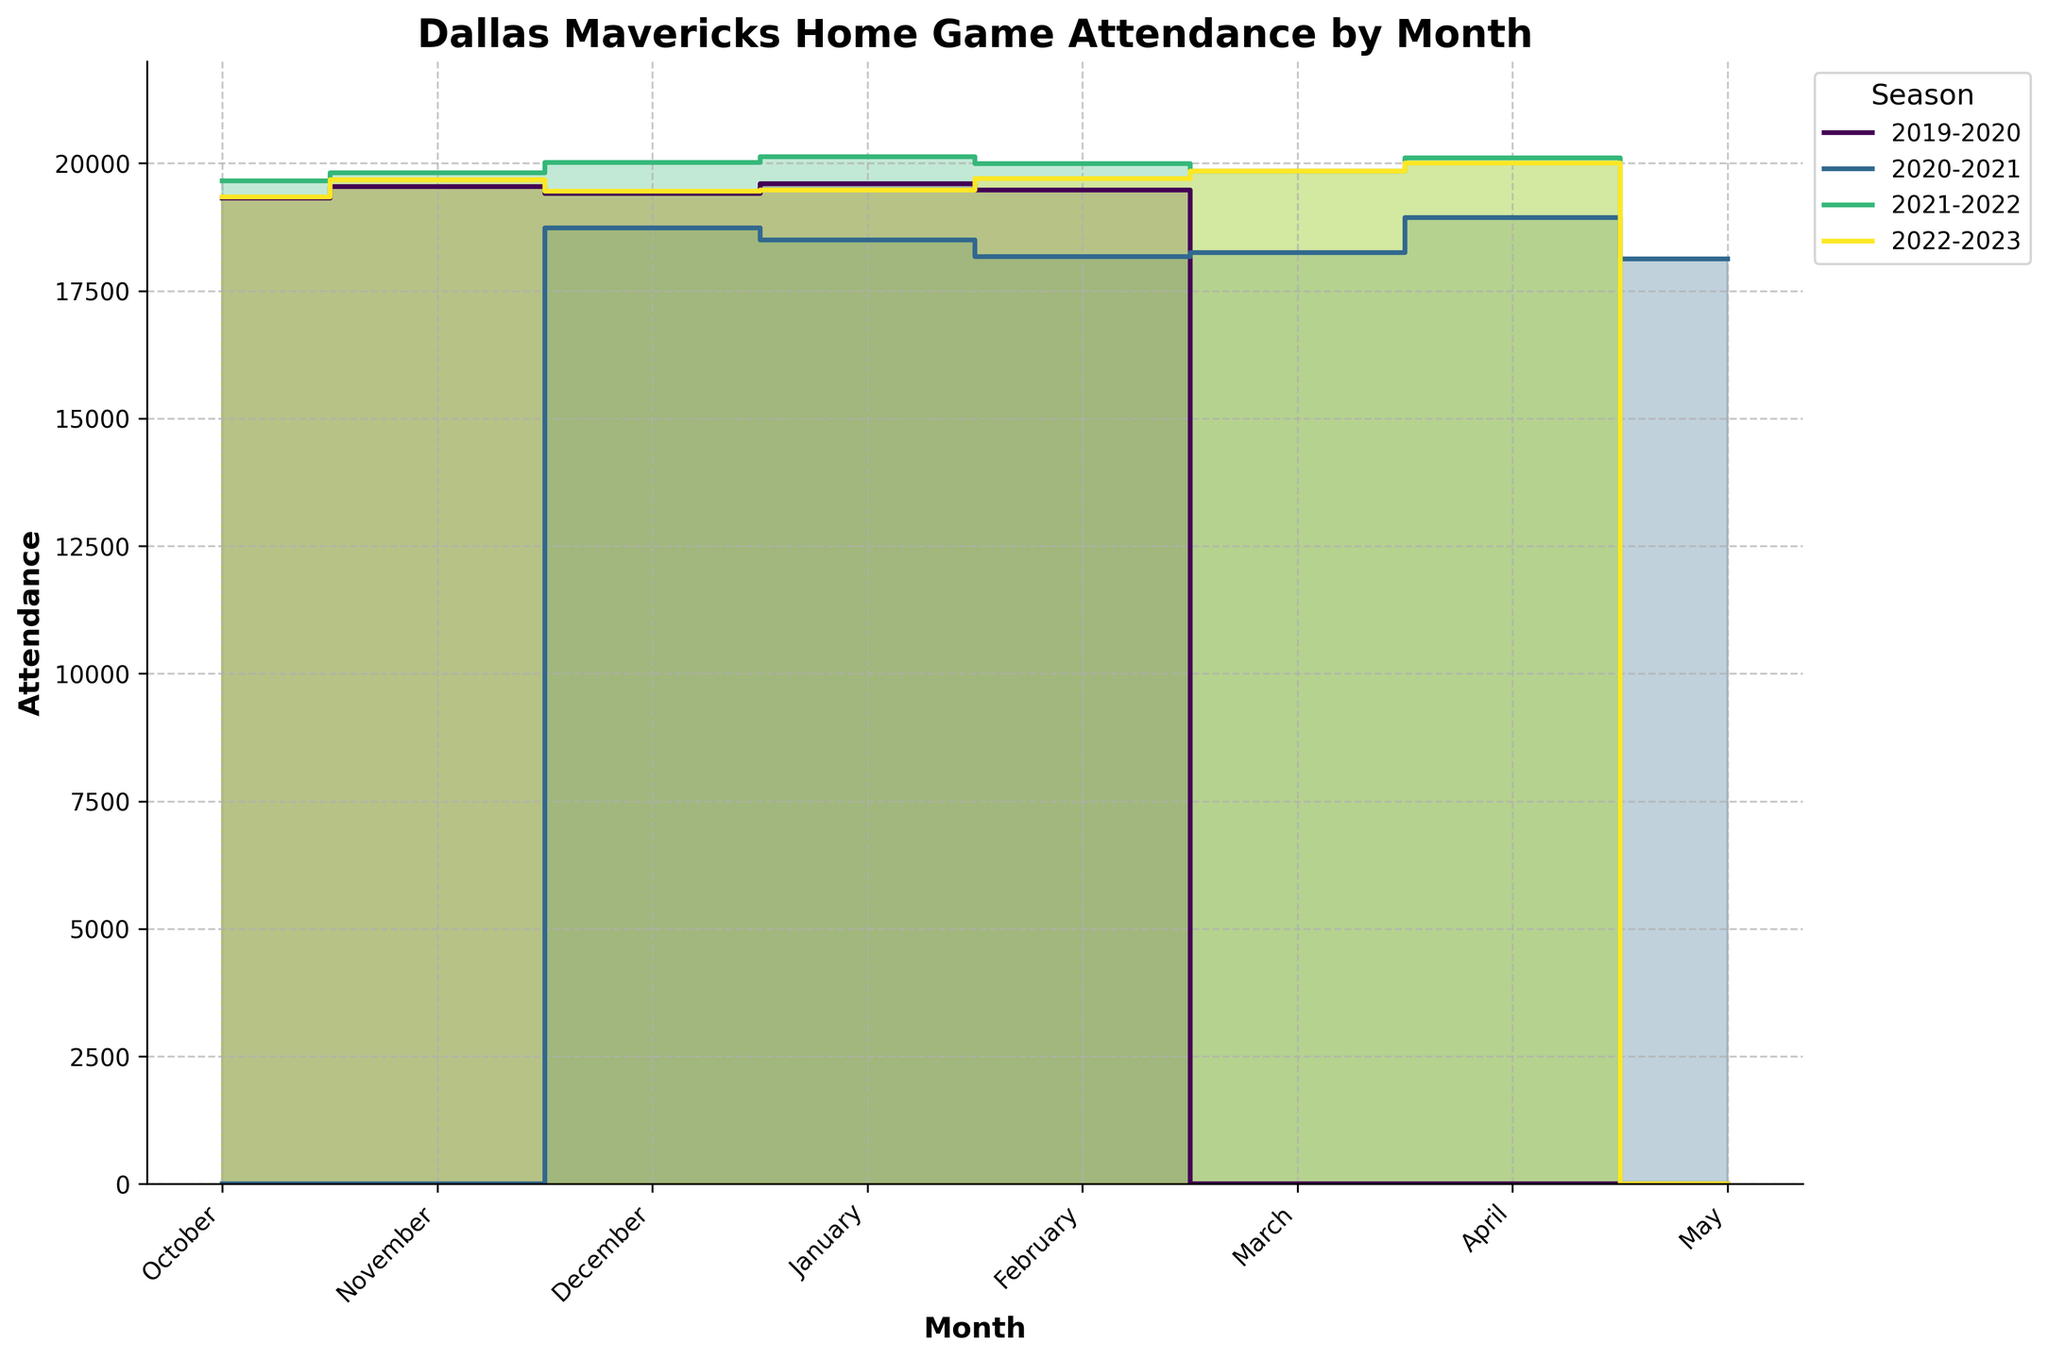What is the title of the chart? The title is usually displayed at the top of the chart. Here, it clearly states "Dallas Mavericks Home Game Attendance by Month".
Answer: Dallas Mavericks Home Game Attendance by Month What month had zero attendance during the 2019-2020 season? By observing the data points for the 2019-2020 season, we can see that March is the month with zero attendance.
Answer: March Which season had the highest attendance in December? For each season, identify the attendance value in December and compare them. 2021-2022 has the highest attendance in December with 20015.
Answer: 2021-2022 How does the attendance in January 2022 compare to January 2023? Find the January data points for the 2021-2022 season (20123) and 2022-2023 season (19480). The attendance in January 2022 is higher.
Answer: Higher in January 2022 What is the average attendance for the 2020-2021 season? The attendances for 2020-2021 season are: December (18732), January (18495), February (18165), March (18250), April (18935) and May (18123). Sum these values and divide by the number of months: (18732 + 18495 + 18165 + 18250 + 18935 + 18123) / 6 = 18483.33.
Answer: 18483.33 Which month generally shows the highest attendance across all seasons? Identify each month's attendance across all seasons and compare. January and April generally show high attendances, but April has 20100 twice, including a peak, making it the top month.
Answer: April What was the trend in attendance from October to March in the 2021-2022 season? Observing the 2021-2022 season, the attendance starts at 19654 in October and generally increases till January (20123), and then it slightly decreases until March (19845). The trend shows a rising pattern till January, slightly decreasing afterward.
Answer: Rising till January, slight decrease afterward What is the total attendance for the 2021-2022 season? Sum the attendance values for each month in the 2021-2022 season: (19654 + 19812 + 20015 + 20123 + 19987 + 19845 + 20100) = 139536.
Answer: 139536 